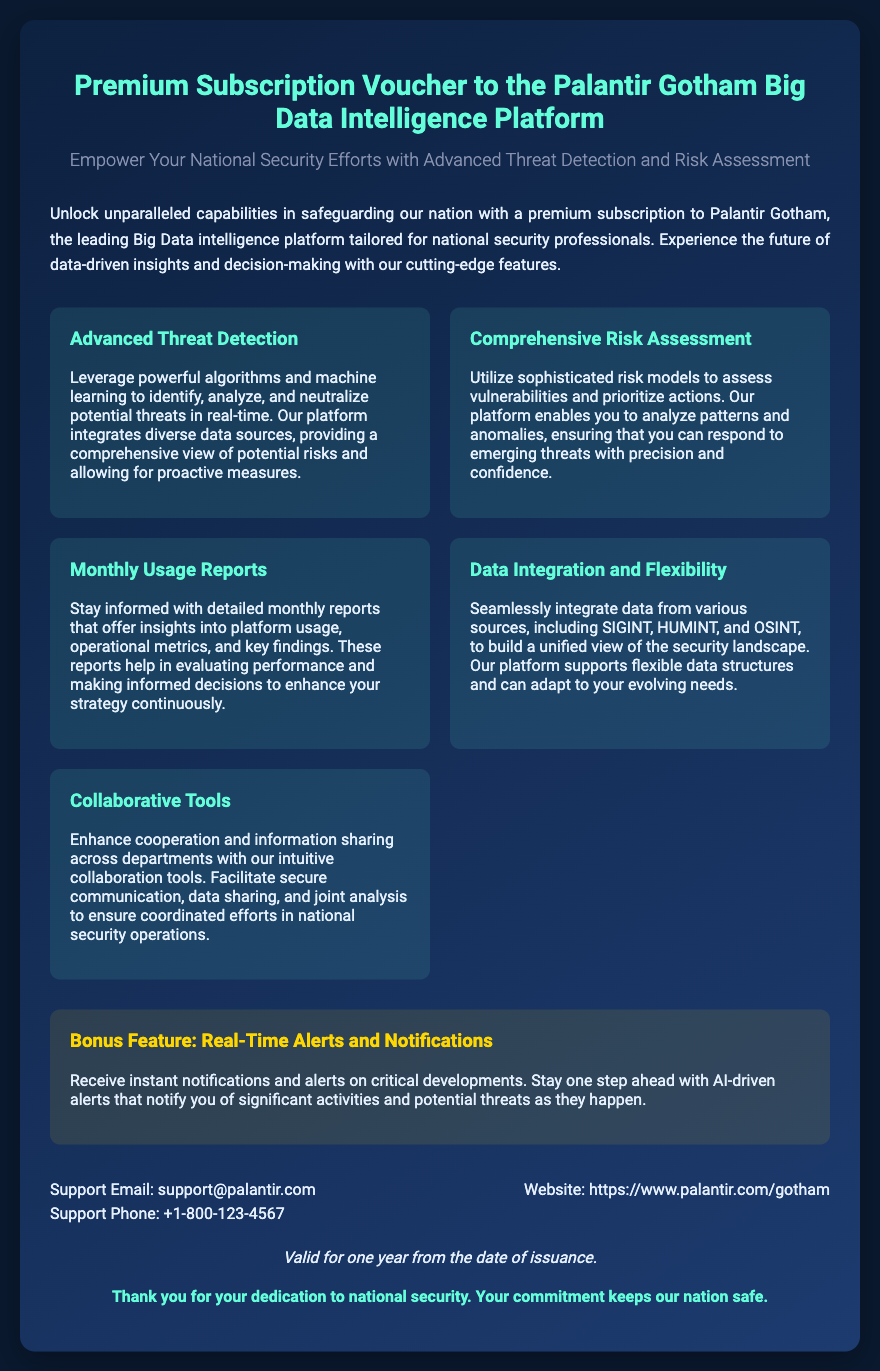What is the title of the voucher? The title of the voucher states the type of subscription that it offers, which is "Premium Subscription Voucher to the Palantir Gotham Big Data Intelligence Platform."
Answer: Premium Subscription Voucher to the Palantir Gotham Big Data Intelligence Platform What is the main purpose of the platform? The main purpose of the platform, as described, is to empower national security efforts with advanced threat detection and risk assessment.
Answer: Empower Your National Security Efforts What is one feature included in the premium subscription? The document lists several features included in the premium subscription, one of which is "Advanced Threat Detection."
Answer: Advanced Threat Detection How long is the voucher valid for? The validity of the voucher is specifically mentioned in the document stating it is "Valid for one year from the date of issuance."
Answer: One year What bonus feature is highlighted in the document? The document includes a specific mention of a bonus feature which is "Real-Time Alerts and Notifications."
Answer: Real-Time Alerts and Notifications What type of tools does the platform offer for collaboration? The document refers to the tools available for collaboration as "Collaborative Tools."
Answer: Collaborative Tools How can you contact support? The document provides contact information for support, specifically an email and phone number: "support@palantir.com" and "+1-800-123-4567."
Answer: support@palantir.com What monthly report is provided to the users? The document states that users receive "Monthly Usage Reports" to keep informed about usage, metrics, and findings.
Answer: Monthly Usage Reports What two types of intelligence does the platform integrate data from? The document specifically mentions "SIGINT" and "HUMINT" as types of intelligence from which the platform integrates data.
Answer: SIGINT and HUMINT 